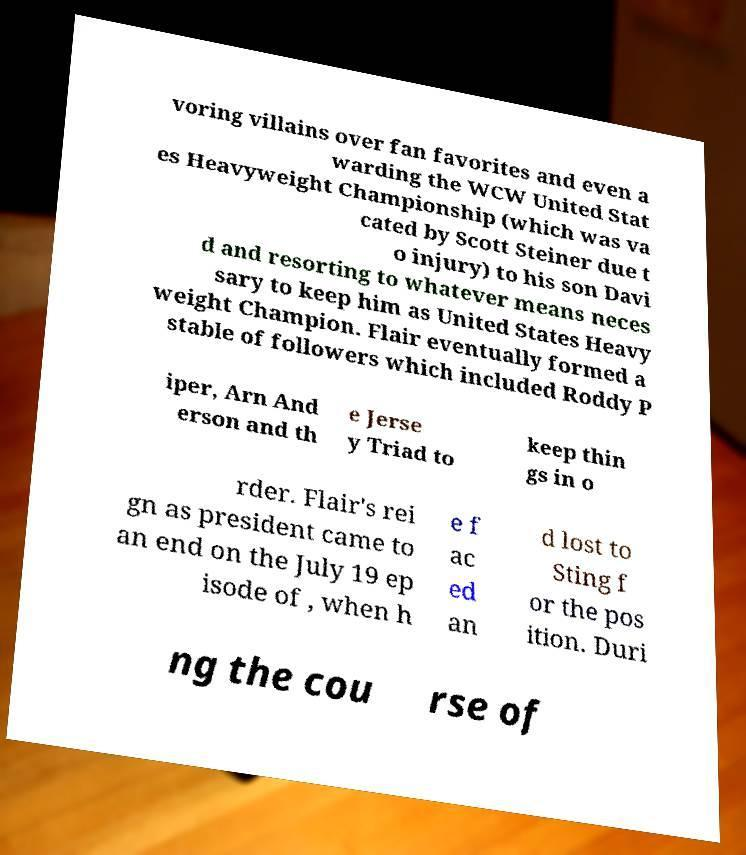Please identify and transcribe the text found in this image. voring villains over fan favorites and even a warding the WCW United Stat es Heavyweight Championship (which was va cated by Scott Steiner due t o injury) to his son Davi d and resorting to whatever means neces sary to keep him as United States Heavy weight Champion. Flair eventually formed a stable of followers which included Roddy P iper, Arn And erson and th e Jerse y Triad to keep thin gs in o rder. Flair's rei gn as president came to an end on the July 19 ep isode of , when h e f ac ed an d lost to Sting f or the pos ition. Duri ng the cou rse of 